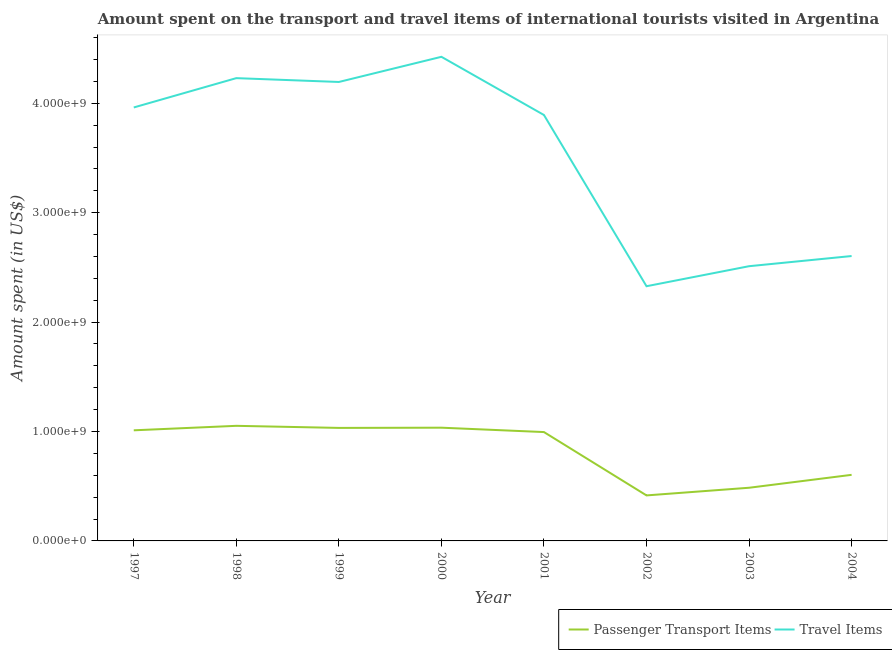How many different coloured lines are there?
Ensure brevity in your answer.  2. Does the line corresponding to amount spent on passenger transport items intersect with the line corresponding to amount spent in travel items?
Offer a terse response. No. What is the amount spent on passenger transport items in 1999?
Offer a terse response. 1.03e+09. Across all years, what is the maximum amount spent in travel items?
Provide a succinct answer. 4.42e+09. Across all years, what is the minimum amount spent in travel items?
Offer a terse response. 2.33e+09. In which year was the amount spent on passenger transport items maximum?
Make the answer very short. 1998. What is the total amount spent on passenger transport items in the graph?
Ensure brevity in your answer.  6.63e+09. What is the difference between the amount spent in travel items in 1997 and that in 2001?
Your response must be concise. 6.90e+07. What is the difference between the amount spent in travel items in 1998 and the amount spent on passenger transport items in 2001?
Your answer should be compact. 3.24e+09. What is the average amount spent in travel items per year?
Your answer should be compact. 3.52e+09. In the year 2000, what is the difference between the amount spent on passenger transport items and amount spent in travel items?
Ensure brevity in your answer.  -3.39e+09. In how many years, is the amount spent on passenger transport items greater than 3000000000 US$?
Provide a succinct answer. 0. What is the ratio of the amount spent on passenger transport items in 1999 to that in 2000?
Provide a short and direct response. 1. What is the difference between the highest and the second highest amount spent on passenger transport items?
Offer a very short reply. 1.70e+07. What is the difference between the highest and the lowest amount spent on passenger transport items?
Keep it short and to the point. 6.36e+08. Is the amount spent in travel items strictly greater than the amount spent on passenger transport items over the years?
Offer a terse response. Yes. Is the amount spent in travel items strictly less than the amount spent on passenger transport items over the years?
Make the answer very short. No. Does the graph contain any zero values?
Give a very brief answer. No. How many legend labels are there?
Give a very brief answer. 2. How are the legend labels stacked?
Keep it short and to the point. Horizontal. What is the title of the graph?
Provide a short and direct response. Amount spent on the transport and travel items of international tourists visited in Argentina. Does "Investment in Transport" appear as one of the legend labels in the graph?
Provide a short and direct response. No. What is the label or title of the X-axis?
Provide a short and direct response. Year. What is the label or title of the Y-axis?
Your answer should be very brief. Amount spent (in US$). What is the Amount spent (in US$) in Passenger Transport Items in 1997?
Provide a short and direct response. 1.01e+09. What is the Amount spent (in US$) in Travel Items in 1997?
Your response must be concise. 3.96e+09. What is the Amount spent (in US$) in Passenger Transport Items in 1998?
Keep it short and to the point. 1.05e+09. What is the Amount spent (in US$) in Travel Items in 1998?
Keep it short and to the point. 4.23e+09. What is the Amount spent (in US$) in Passenger Transport Items in 1999?
Give a very brief answer. 1.03e+09. What is the Amount spent (in US$) of Travel Items in 1999?
Offer a terse response. 4.20e+09. What is the Amount spent (in US$) in Passenger Transport Items in 2000?
Offer a very short reply. 1.04e+09. What is the Amount spent (in US$) in Travel Items in 2000?
Offer a very short reply. 4.42e+09. What is the Amount spent (in US$) in Passenger Transport Items in 2001?
Provide a short and direct response. 9.95e+08. What is the Amount spent (in US$) in Travel Items in 2001?
Give a very brief answer. 3.89e+09. What is the Amount spent (in US$) in Passenger Transport Items in 2002?
Give a very brief answer. 4.16e+08. What is the Amount spent (in US$) in Travel Items in 2002?
Give a very brief answer. 2.33e+09. What is the Amount spent (in US$) of Passenger Transport Items in 2003?
Ensure brevity in your answer.  4.86e+08. What is the Amount spent (in US$) in Travel Items in 2003?
Your response must be concise. 2.51e+09. What is the Amount spent (in US$) of Passenger Transport Items in 2004?
Provide a short and direct response. 6.04e+08. What is the Amount spent (in US$) in Travel Items in 2004?
Your answer should be very brief. 2.60e+09. Across all years, what is the maximum Amount spent (in US$) of Passenger Transport Items?
Offer a very short reply. 1.05e+09. Across all years, what is the maximum Amount spent (in US$) in Travel Items?
Provide a succinct answer. 4.42e+09. Across all years, what is the minimum Amount spent (in US$) in Passenger Transport Items?
Provide a succinct answer. 4.16e+08. Across all years, what is the minimum Amount spent (in US$) of Travel Items?
Offer a terse response. 2.33e+09. What is the total Amount spent (in US$) of Passenger Transport Items in the graph?
Provide a succinct answer. 6.63e+09. What is the total Amount spent (in US$) of Travel Items in the graph?
Provide a short and direct response. 2.81e+1. What is the difference between the Amount spent (in US$) in Passenger Transport Items in 1997 and that in 1998?
Keep it short and to the point. -4.10e+07. What is the difference between the Amount spent (in US$) of Travel Items in 1997 and that in 1998?
Keep it short and to the point. -2.68e+08. What is the difference between the Amount spent (in US$) in Passenger Transport Items in 1997 and that in 1999?
Your answer should be very brief. -2.20e+07. What is the difference between the Amount spent (in US$) of Travel Items in 1997 and that in 1999?
Keep it short and to the point. -2.33e+08. What is the difference between the Amount spent (in US$) of Passenger Transport Items in 1997 and that in 2000?
Provide a short and direct response. -2.40e+07. What is the difference between the Amount spent (in US$) in Travel Items in 1997 and that in 2000?
Keep it short and to the point. -4.63e+08. What is the difference between the Amount spent (in US$) in Passenger Transport Items in 1997 and that in 2001?
Provide a succinct answer. 1.60e+07. What is the difference between the Amount spent (in US$) of Travel Items in 1997 and that in 2001?
Offer a terse response. 6.90e+07. What is the difference between the Amount spent (in US$) of Passenger Transport Items in 1997 and that in 2002?
Keep it short and to the point. 5.95e+08. What is the difference between the Amount spent (in US$) of Travel Items in 1997 and that in 2002?
Give a very brief answer. 1.63e+09. What is the difference between the Amount spent (in US$) in Passenger Transport Items in 1997 and that in 2003?
Make the answer very short. 5.25e+08. What is the difference between the Amount spent (in US$) in Travel Items in 1997 and that in 2003?
Your answer should be very brief. 1.45e+09. What is the difference between the Amount spent (in US$) of Passenger Transport Items in 1997 and that in 2004?
Your answer should be compact. 4.07e+08. What is the difference between the Amount spent (in US$) of Travel Items in 1997 and that in 2004?
Ensure brevity in your answer.  1.36e+09. What is the difference between the Amount spent (in US$) of Passenger Transport Items in 1998 and that in 1999?
Provide a short and direct response. 1.90e+07. What is the difference between the Amount spent (in US$) in Travel Items in 1998 and that in 1999?
Keep it short and to the point. 3.50e+07. What is the difference between the Amount spent (in US$) in Passenger Transport Items in 1998 and that in 2000?
Provide a short and direct response. 1.70e+07. What is the difference between the Amount spent (in US$) in Travel Items in 1998 and that in 2000?
Your answer should be very brief. -1.95e+08. What is the difference between the Amount spent (in US$) in Passenger Transport Items in 1998 and that in 2001?
Your answer should be compact. 5.70e+07. What is the difference between the Amount spent (in US$) in Travel Items in 1998 and that in 2001?
Keep it short and to the point. 3.37e+08. What is the difference between the Amount spent (in US$) in Passenger Transport Items in 1998 and that in 2002?
Your answer should be very brief. 6.36e+08. What is the difference between the Amount spent (in US$) of Travel Items in 1998 and that in 2002?
Offer a terse response. 1.90e+09. What is the difference between the Amount spent (in US$) of Passenger Transport Items in 1998 and that in 2003?
Keep it short and to the point. 5.66e+08. What is the difference between the Amount spent (in US$) of Travel Items in 1998 and that in 2003?
Your answer should be compact. 1.72e+09. What is the difference between the Amount spent (in US$) in Passenger Transport Items in 1998 and that in 2004?
Your answer should be compact. 4.48e+08. What is the difference between the Amount spent (in US$) of Travel Items in 1998 and that in 2004?
Give a very brief answer. 1.63e+09. What is the difference between the Amount spent (in US$) of Travel Items in 1999 and that in 2000?
Offer a very short reply. -2.30e+08. What is the difference between the Amount spent (in US$) in Passenger Transport Items in 1999 and that in 2001?
Keep it short and to the point. 3.80e+07. What is the difference between the Amount spent (in US$) in Travel Items in 1999 and that in 2001?
Ensure brevity in your answer.  3.02e+08. What is the difference between the Amount spent (in US$) of Passenger Transport Items in 1999 and that in 2002?
Make the answer very short. 6.17e+08. What is the difference between the Amount spent (in US$) of Travel Items in 1999 and that in 2002?
Keep it short and to the point. 1.87e+09. What is the difference between the Amount spent (in US$) of Passenger Transport Items in 1999 and that in 2003?
Keep it short and to the point. 5.47e+08. What is the difference between the Amount spent (in US$) of Travel Items in 1999 and that in 2003?
Offer a terse response. 1.68e+09. What is the difference between the Amount spent (in US$) of Passenger Transport Items in 1999 and that in 2004?
Ensure brevity in your answer.  4.29e+08. What is the difference between the Amount spent (in US$) of Travel Items in 1999 and that in 2004?
Keep it short and to the point. 1.59e+09. What is the difference between the Amount spent (in US$) of Passenger Transport Items in 2000 and that in 2001?
Make the answer very short. 4.00e+07. What is the difference between the Amount spent (in US$) in Travel Items in 2000 and that in 2001?
Provide a succinct answer. 5.32e+08. What is the difference between the Amount spent (in US$) of Passenger Transport Items in 2000 and that in 2002?
Offer a very short reply. 6.19e+08. What is the difference between the Amount spent (in US$) of Travel Items in 2000 and that in 2002?
Make the answer very short. 2.10e+09. What is the difference between the Amount spent (in US$) in Passenger Transport Items in 2000 and that in 2003?
Your answer should be compact. 5.49e+08. What is the difference between the Amount spent (in US$) of Travel Items in 2000 and that in 2003?
Offer a terse response. 1.91e+09. What is the difference between the Amount spent (in US$) in Passenger Transport Items in 2000 and that in 2004?
Offer a very short reply. 4.31e+08. What is the difference between the Amount spent (in US$) in Travel Items in 2000 and that in 2004?
Your answer should be very brief. 1.82e+09. What is the difference between the Amount spent (in US$) of Passenger Transport Items in 2001 and that in 2002?
Your answer should be compact. 5.79e+08. What is the difference between the Amount spent (in US$) in Travel Items in 2001 and that in 2002?
Provide a short and direct response. 1.56e+09. What is the difference between the Amount spent (in US$) in Passenger Transport Items in 2001 and that in 2003?
Offer a very short reply. 5.09e+08. What is the difference between the Amount spent (in US$) of Travel Items in 2001 and that in 2003?
Provide a succinct answer. 1.38e+09. What is the difference between the Amount spent (in US$) in Passenger Transport Items in 2001 and that in 2004?
Make the answer very short. 3.91e+08. What is the difference between the Amount spent (in US$) of Travel Items in 2001 and that in 2004?
Make the answer very short. 1.29e+09. What is the difference between the Amount spent (in US$) in Passenger Transport Items in 2002 and that in 2003?
Your answer should be very brief. -7.00e+07. What is the difference between the Amount spent (in US$) of Travel Items in 2002 and that in 2003?
Make the answer very short. -1.83e+08. What is the difference between the Amount spent (in US$) in Passenger Transport Items in 2002 and that in 2004?
Provide a short and direct response. -1.88e+08. What is the difference between the Amount spent (in US$) in Travel Items in 2002 and that in 2004?
Offer a terse response. -2.76e+08. What is the difference between the Amount spent (in US$) of Passenger Transport Items in 2003 and that in 2004?
Your answer should be compact. -1.18e+08. What is the difference between the Amount spent (in US$) in Travel Items in 2003 and that in 2004?
Your answer should be very brief. -9.30e+07. What is the difference between the Amount spent (in US$) in Passenger Transport Items in 1997 and the Amount spent (in US$) in Travel Items in 1998?
Keep it short and to the point. -3.22e+09. What is the difference between the Amount spent (in US$) in Passenger Transport Items in 1997 and the Amount spent (in US$) in Travel Items in 1999?
Offer a very short reply. -3.18e+09. What is the difference between the Amount spent (in US$) of Passenger Transport Items in 1997 and the Amount spent (in US$) of Travel Items in 2000?
Your response must be concise. -3.41e+09. What is the difference between the Amount spent (in US$) of Passenger Transport Items in 1997 and the Amount spent (in US$) of Travel Items in 2001?
Keep it short and to the point. -2.88e+09. What is the difference between the Amount spent (in US$) in Passenger Transport Items in 1997 and the Amount spent (in US$) in Travel Items in 2002?
Keep it short and to the point. -1.32e+09. What is the difference between the Amount spent (in US$) in Passenger Transport Items in 1997 and the Amount spent (in US$) in Travel Items in 2003?
Offer a very short reply. -1.50e+09. What is the difference between the Amount spent (in US$) in Passenger Transport Items in 1997 and the Amount spent (in US$) in Travel Items in 2004?
Your answer should be very brief. -1.59e+09. What is the difference between the Amount spent (in US$) in Passenger Transport Items in 1998 and the Amount spent (in US$) in Travel Items in 1999?
Offer a terse response. -3.14e+09. What is the difference between the Amount spent (in US$) of Passenger Transport Items in 1998 and the Amount spent (in US$) of Travel Items in 2000?
Offer a terse response. -3.37e+09. What is the difference between the Amount spent (in US$) in Passenger Transport Items in 1998 and the Amount spent (in US$) in Travel Items in 2001?
Give a very brief answer. -2.84e+09. What is the difference between the Amount spent (in US$) of Passenger Transport Items in 1998 and the Amount spent (in US$) of Travel Items in 2002?
Keep it short and to the point. -1.28e+09. What is the difference between the Amount spent (in US$) in Passenger Transport Items in 1998 and the Amount spent (in US$) in Travel Items in 2003?
Give a very brief answer. -1.46e+09. What is the difference between the Amount spent (in US$) of Passenger Transport Items in 1998 and the Amount spent (in US$) of Travel Items in 2004?
Ensure brevity in your answer.  -1.55e+09. What is the difference between the Amount spent (in US$) of Passenger Transport Items in 1999 and the Amount spent (in US$) of Travel Items in 2000?
Your answer should be compact. -3.39e+09. What is the difference between the Amount spent (in US$) of Passenger Transport Items in 1999 and the Amount spent (in US$) of Travel Items in 2001?
Offer a terse response. -2.86e+09. What is the difference between the Amount spent (in US$) in Passenger Transport Items in 1999 and the Amount spent (in US$) in Travel Items in 2002?
Your response must be concise. -1.30e+09. What is the difference between the Amount spent (in US$) of Passenger Transport Items in 1999 and the Amount spent (in US$) of Travel Items in 2003?
Provide a succinct answer. -1.48e+09. What is the difference between the Amount spent (in US$) of Passenger Transport Items in 1999 and the Amount spent (in US$) of Travel Items in 2004?
Keep it short and to the point. -1.57e+09. What is the difference between the Amount spent (in US$) in Passenger Transport Items in 2000 and the Amount spent (in US$) in Travel Items in 2001?
Offer a very short reply. -2.86e+09. What is the difference between the Amount spent (in US$) of Passenger Transport Items in 2000 and the Amount spent (in US$) of Travel Items in 2002?
Your response must be concise. -1.29e+09. What is the difference between the Amount spent (in US$) of Passenger Transport Items in 2000 and the Amount spent (in US$) of Travel Items in 2003?
Your answer should be very brief. -1.48e+09. What is the difference between the Amount spent (in US$) of Passenger Transport Items in 2000 and the Amount spent (in US$) of Travel Items in 2004?
Provide a short and direct response. -1.57e+09. What is the difference between the Amount spent (in US$) of Passenger Transport Items in 2001 and the Amount spent (in US$) of Travel Items in 2002?
Your answer should be compact. -1.33e+09. What is the difference between the Amount spent (in US$) in Passenger Transport Items in 2001 and the Amount spent (in US$) in Travel Items in 2003?
Give a very brief answer. -1.52e+09. What is the difference between the Amount spent (in US$) in Passenger Transport Items in 2001 and the Amount spent (in US$) in Travel Items in 2004?
Keep it short and to the point. -1.61e+09. What is the difference between the Amount spent (in US$) of Passenger Transport Items in 2002 and the Amount spent (in US$) of Travel Items in 2003?
Offer a very short reply. -2.10e+09. What is the difference between the Amount spent (in US$) in Passenger Transport Items in 2002 and the Amount spent (in US$) in Travel Items in 2004?
Your response must be concise. -2.19e+09. What is the difference between the Amount spent (in US$) of Passenger Transport Items in 2003 and the Amount spent (in US$) of Travel Items in 2004?
Your response must be concise. -2.12e+09. What is the average Amount spent (in US$) in Passenger Transport Items per year?
Keep it short and to the point. 8.29e+08. What is the average Amount spent (in US$) of Travel Items per year?
Your answer should be very brief. 3.52e+09. In the year 1997, what is the difference between the Amount spent (in US$) of Passenger Transport Items and Amount spent (in US$) of Travel Items?
Offer a very short reply. -2.95e+09. In the year 1998, what is the difference between the Amount spent (in US$) in Passenger Transport Items and Amount spent (in US$) in Travel Items?
Offer a terse response. -3.18e+09. In the year 1999, what is the difference between the Amount spent (in US$) in Passenger Transport Items and Amount spent (in US$) in Travel Items?
Your response must be concise. -3.16e+09. In the year 2000, what is the difference between the Amount spent (in US$) in Passenger Transport Items and Amount spent (in US$) in Travel Items?
Your answer should be very brief. -3.39e+09. In the year 2001, what is the difference between the Amount spent (in US$) of Passenger Transport Items and Amount spent (in US$) of Travel Items?
Your response must be concise. -2.90e+09. In the year 2002, what is the difference between the Amount spent (in US$) in Passenger Transport Items and Amount spent (in US$) in Travel Items?
Keep it short and to the point. -1.91e+09. In the year 2003, what is the difference between the Amount spent (in US$) in Passenger Transport Items and Amount spent (in US$) in Travel Items?
Keep it short and to the point. -2.02e+09. In the year 2004, what is the difference between the Amount spent (in US$) of Passenger Transport Items and Amount spent (in US$) of Travel Items?
Your answer should be very brief. -2.00e+09. What is the ratio of the Amount spent (in US$) of Travel Items in 1997 to that in 1998?
Your answer should be compact. 0.94. What is the ratio of the Amount spent (in US$) of Passenger Transport Items in 1997 to that in 1999?
Make the answer very short. 0.98. What is the ratio of the Amount spent (in US$) of Travel Items in 1997 to that in 1999?
Ensure brevity in your answer.  0.94. What is the ratio of the Amount spent (in US$) in Passenger Transport Items in 1997 to that in 2000?
Provide a succinct answer. 0.98. What is the ratio of the Amount spent (in US$) of Travel Items in 1997 to that in 2000?
Your answer should be compact. 0.9. What is the ratio of the Amount spent (in US$) in Passenger Transport Items in 1997 to that in 2001?
Ensure brevity in your answer.  1.02. What is the ratio of the Amount spent (in US$) of Travel Items in 1997 to that in 2001?
Your answer should be very brief. 1.02. What is the ratio of the Amount spent (in US$) of Passenger Transport Items in 1997 to that in 2002?
Provide a succinct answer. 2.43. What is the ratio of the Amount spent (in US$) of Travel Items in 1997 to that in 2002?
Offer a very short reply. 1.7. What is the ratio of the Amount spent (in US$) in Passenger Transport Items in 1997 to that in 2003?
Provide a succinct answer. 2.08. What is the ratio of the Amount spent (in US$) in Travel Items in 1997 to that in 2003?
Provide a short and direct response. 1.58. What is the ratio of the Amount spent (in US$) of Passenger Transport Items in 1997 to that in 2004?
Your response must be concise. 1.67. What is the ratio of the Amount spent (in US$) in Travel Items in 1997 to that in 2004?
Make the answer very short. 1.52. What is the ratio of the Amount spent (in US$) in Passenger Transport Items in 1998 to that in 1999?
Your answer should be very brief. 1.02. What is the ratio of the Amount spent (in US$) in Travel Items in 1998 to that in 1999?
Your response must be concise. 1.01. What is the ratio of the Amount spent (in US$) in Passenger Transport Items in 1998 to that in 2000?
Provide a short and direct response. 1.02. What is the ratio of the Amount spent (in US$) in Travel Items in 1998 to that in 2000?
Your response must be concise. 0.96. What is the ratio of the Amount spent (in US$) in Passenger Transport Items in 1998 to that in 2001?
Ensure brevity in your answer.  1.06. What is the ratio of the Amount spent (in US$) of Travel Items in 1998 to that in 2001?
Make the answer very short. 1.09. What is the ratio of the Amount spent (in US$) of Passenger Transport Items in 1998 to that in 2002?
Offer a very short reply. 2.53. What is the ratio of the Amount spent (in US$) of Travel Items in 1998 to that in 2002?
Provide a short and direct response. 1.82. What is the ratio of the Amount spent (in US$) in Passenger Transport Items in 1998 to that in 2003?
Your answer should be very brief. 2.16. What is the ratio of the Amount spent (in US$) in Travel Items in 1998 to that in 2003?
Keep it short and to the point. 1.68. What is the ratio of the Amount spent (in US$) of Passenger Transport Items in 1998 to that in 2004?
Give a very brief answer. 1.74. What is the ratio of the Amount spent (in US$) in Travel Items in 1998 to that in 2004?
Your response must be concise. 1.62. What is the ratio of the Amount spent (in US$) of Passenger Transport Items in 1999 to that in 2000?
Make the answer very short. 1. What is the ratio of the Amount spent (in US$) in Travel Items in 1999 to that in 2000?
Keep it short and to the point. 0.95. What is the ratio of the Amount spent (in US$) of Passenger Transport Items in 1999 to that in 2001?
Provide a short and direct response. 1.04. What is the ratio of the Amount spent (in US$) in Travel Items in 1999 to that in 2001?
Give a very brief answer. 1.08. What is the ratio of the Amount spent (in US$) in Passenger Transport Items in 1999 to that in 2002?
Ensure brevity in your answer.  2.48. What is the ratio of the Amount spent (in US$) of Travel Items in 1999 to that in 2002?
Your answer should be compact. 1.8. What is the ratio of the Amount spent (in US$) in Passenger Transport Items in 1999 to that in 2003?
Ensure brevity in your answer.  2.13. What is the ratio of the Amount spent (in US$) of Travel Items in 1999 to that in 2003?
Provide a short and direct response. 1.67. What is the ratio of the Amount spent (in US$) in Passenger Transport Items in 1999 to that in 2004?
Your answer should be very brief. 1.71. What is the ratio of the Amount spent (in US$) of Travel Items in 1999 to that in 2004?
Provide a succinct answer. 1.61. What is the ratio of the Amount spent (in US$) of Passenger Transport Items in 2000 to that in 2001?
Provide a succinct answer. 1.04. What is the ratio of the Amount spent (in US$) in Travel Items in 2000 to that in 2001?
Your response must be concise. 1.14. What is the ratio of the Amount spent (in US$) in Passenger Transport Items in 2000 to that in 2002?
Keep it short and to the point. 2.49. What is the ratio of the Amount spent (in US$) of Travel Items in 2000 to that in 2002?
Your response must be concise. 1.9. What is the ratio of the Amount spent (in US$) in Passenger Transport Items in 2000 to that in 2003?
Your answer should be compact. 2.13. What is the ratio of the Amount spent (in US$) in Travel Items in 2000 to that in 2003?
Keep it short and to the point. 1.76. What is the ratio of the Amount spent (in US$) of Passenger Transport Items in 2000 to that in 2004?
Offer a terse response. 1.71. What is the ratio of the Amount spent (in US$) in Travel Items in 2000 to that in 2004?
Provide a succinct answer. 1.7. What is the ratio of the Amount spent (in US$) in Passenger Transport Items in 2001 to that in 2002?
Offer a terse response. 2.39. What is the ratio of the Amount spent (in US$) in Travel Items in 2001 to that in 2002?
Provide a short and direct response. 1.67. What is the ratio of the Amount spent (in US$) in Passenger Transport Items in 2001 to that in 2003?
Give a very brief answer. 2.05. What is the ratio of the Amount spent (in US$) of Travel Items in 2001 to that in 2003?
Provide a short and direct response. 1.55. What is the ratio of the Amount spent (in US$) of Passenger Transport Items in 2001 to that in 2004?
Provide a succinct answer. 1.65. What is the ratio of the Amount spent (in US$) of Travel Items in 2001 to that in 2004?
Ensure brevity in your answer.  1.5. What is the ratio of the Amount spent (in US$) of Passenger Transport Items in 2002 to that in 2003?
Your answer should be compact. 0.86. What is the ratio of the Amount spent (in US$) in Travel Items in 2002 to that in 2003?
Offer a very short reply. 0.93. What is the ratio of the Amount spent (in US$) of Passenger Transport Items in 2002 to that in 2004?
Provide a short and direct response. 0.69. What is the ratio of the Amount spent (in US$) of Travel Items in 2002 to that in 2004?
Your answer should be compact. 0.89. What is the ratio of the Amount spent (in US$) of Passenger Transport Items in 2003 to that in 2004?
Offer a terse response. 0.8. What is the ratio of the Amount spent (in US$) of Travel Items in 2003 to that in 2004?
Keep it short and to the point. 0.96. What is the difference between the highest and the second highest Amount spent (in US$) of Passenger Transport Items?
Provide a succinct answer. 1.70e+07. What is the difference between the highest and the second highest Amount spent (in US$) in Travel Items?
Ensure brevity in your answer.  1.95e+08. What is the difference between the highest and the lowest Amount spent (in US$) of Passenger Transport Items?
Keep it short and to the point. 6.36e+08. What is the difference between the highest and the lowest Amount spent (in US$) in Travel Items?
Ensure brevity in your answer.  2.10e+09. 